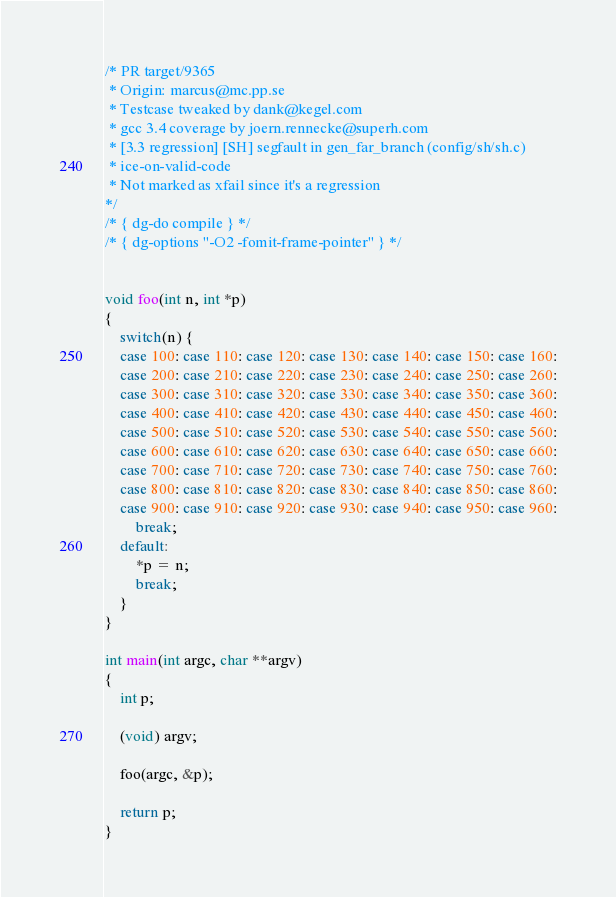Convert code to text. <code><loc_0><loc_0><loc_500><loc_500><_C_>/* PR target/9365
 * Origin: marcus@mc.pp.se
 * Testcase tweaked by dank@kegel.com
 * gcc 3.4 coverage by joern.rennecke@superh.com
 * [3.3 regression] [SH] segfault in gen_far_branch (config/sh/sh.c)
 * ice-on-valid-code
 * Not marked as xfail since it's a regression
*/
/* { dg-do compile } */
/* { dg-options "-O2 -fomit-frame-pointer" } */


void foo(int n, int *p)
{
	switch(n) {
	case 100: case 110: case 120: case 130: case 140: case 150: case 160:
	case 200: case 210: case 220: case 230: case 240: case 250: case 260:
	case 300: case 310: case 320: case 330: case 340: case 350: case 360:
	case 400: case 410: case 420: case 430: case 440: case 450: case 460:
	case 500: case 510: case 520: case 530: case 540: case 550: case 560:
	case 600: case 610: case 620: case 630: case 640: case 650: case 660:
	case 700: case 710: case 720: case 730: case 740: case 750: case 760:
	case 800: case 810: case 820: case 830: case 840: case 850: case 860:
	case 900: case 910: case 920: case 930: case 940: case 950: case 960:
		break;
	default:
		*p = n;
		break;
	}
}

int main(int argc, char **argv)
{
	int p;

	(void) argv;

	foo(argc, &p);

	return p;
}
</code> 